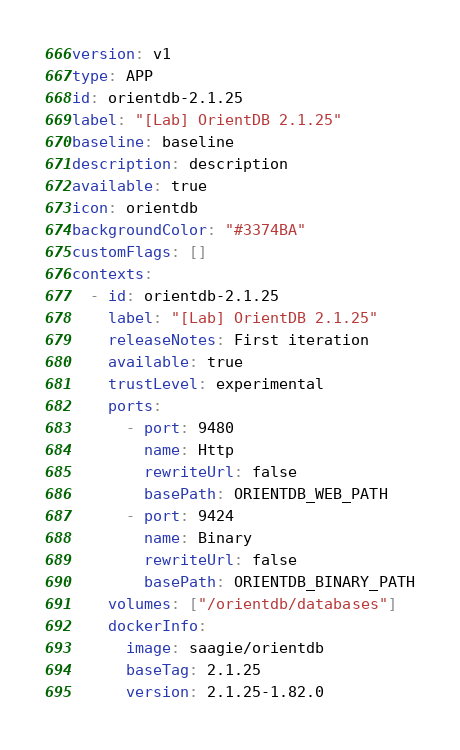Convert code to text. <code><loc_0><loc_0><loc_500><loc_500><_YAML_>version: v1
type: APP
id: orientdb-2.1.25
label: "[Lab] OrientDB 2.1.25"
baseline: baseline
description: description
available: true
icon: orientdb
backgroundColor: "#3374BA"
customFlags: []
contexts:
  - id: orientdb-2.1.25
    label: "[Lab] OrientDB 2.1.25"
    releaseNotes: First iteration
    available: true
    trustLevel: experimental
    ports:
      - port: 9480
        name: Http
        rewriteUrl: false
        basePath: ORIENTDB_WEB_PATH
      - port: 9424
        name: Binary
        rewriteUrl: false
        basePath: ORIENTDB_BINARY_PATH
    volumes: ["/orientdb/databases"]
    dockerInfo:
      image: saagie/orientdb
      baseTag: 2.1.25
      version: 2.1.25-1.82.0</code> 